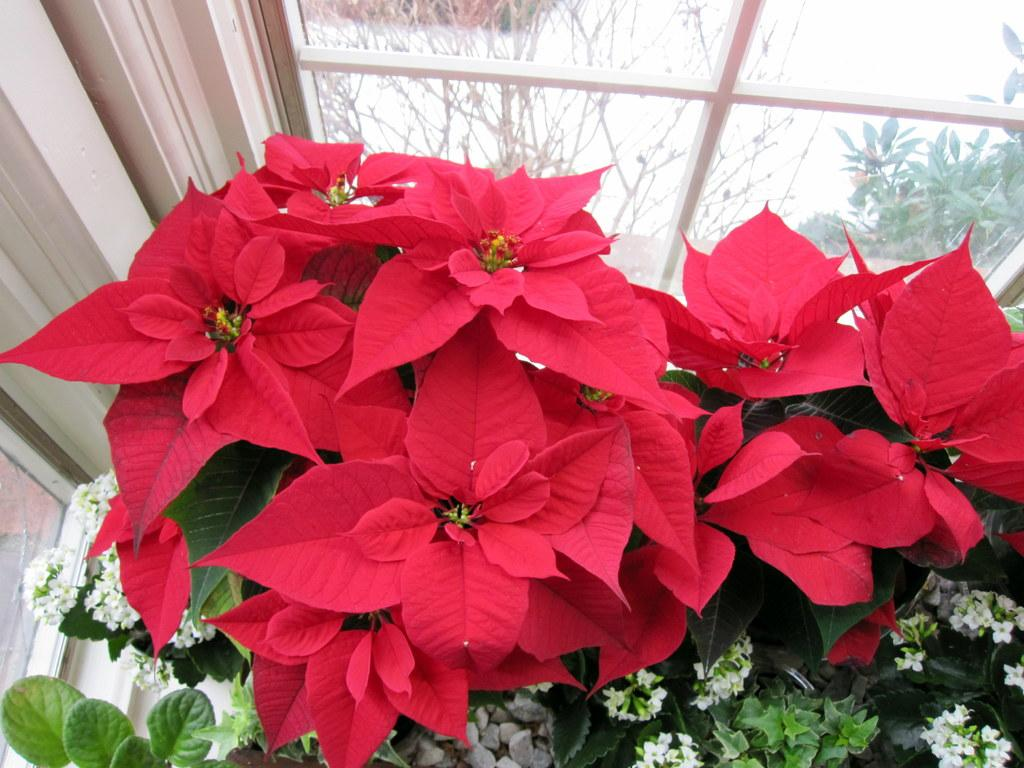What type of plants can be seen in the image? There are flowering plants in the image. What architectural feature is present in the image? There is a pillar in the image. What can be seen through the window in the image? The image does not show what can be seen through the window. Can you determine the time of day the image was taken? The image was likely taken during the day, as there is sufficient light. What type of baby appliance can be seen in the image? There is no baby appliance present in the image. What is the texture of the pillar in the image? The image does not provide enough detail to determine the texture of the pillar. 